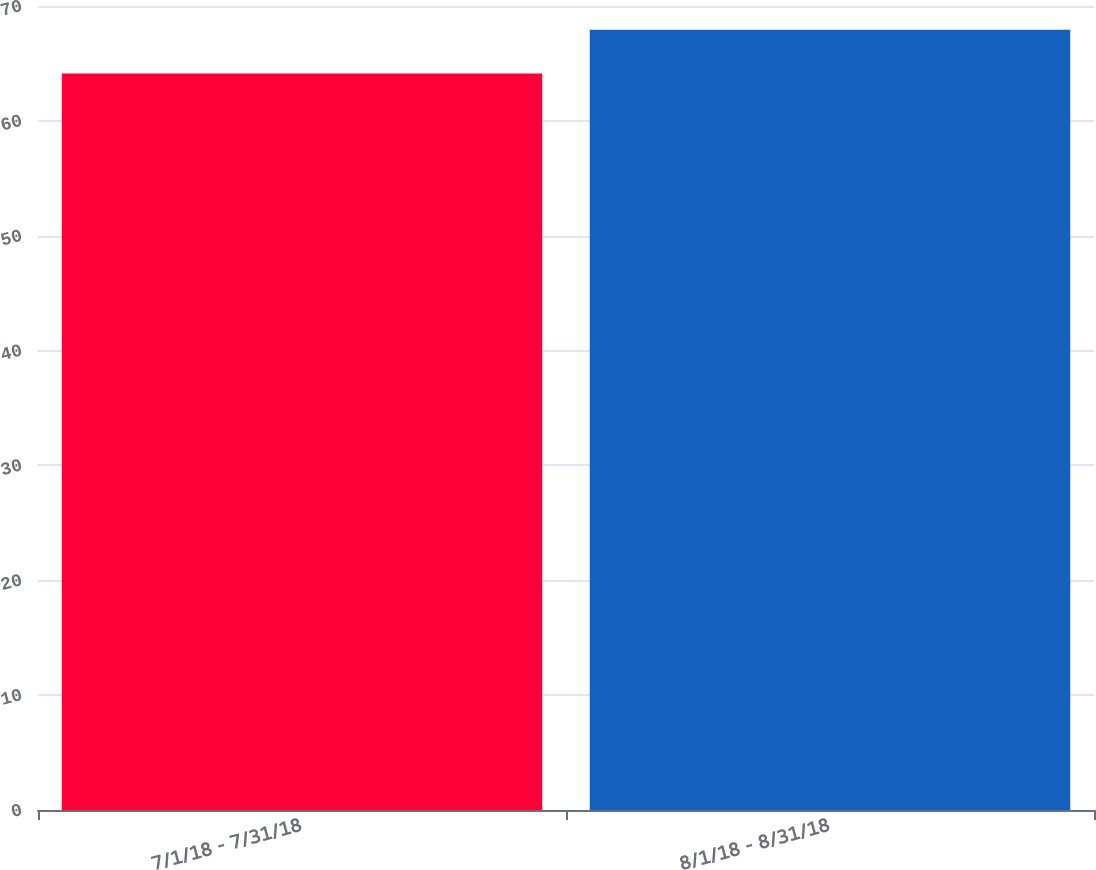Convert chart to OTSL. <chart><loc_0><loc_0><loc_500><loc_500><bar_chart><fcel>7/1/18 - 7/31/18<fcel>8/1/18 - 8/31/18<nl><fcel>64.13<fcel>67.93<nl></chart> 